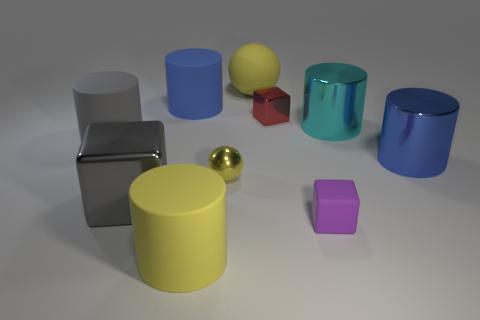How many other things are there of the same color as the rubber ball?
Offer a terse response. 2. What is the shape of the thing that is both behind the gray metallic thing and in front of the big blue metallic cylinder?
Make the answer very short. Sphere. Are there any red metal blocks that are on the left side of the big yellow rubber object in front of the cyan metallic cylinder to the right of the gray rubber cylinder?
Your answer should be compact. No. What number of other things are made of the same material as the red thing?
Ensure brevity in your answer.  4. How many yellow cylinders are there?
Your answer should be very brief. 1. How many things are either cylinders or big rubber cylinders behind the small purple matte cube?
Your answer should be compact. 5. Are there any other things that have the same shape as the big blue matte object?
Ensure brevity in your answer.  Yes. Is the size of the blue cylinder that is right of the yellow rubber cylinder the same as the big cyan cylinder?
Keep it short and to the point. Yes. What number of rubber objects are tiny yellow balls or big gray things?
Offer a very short reply. 1. What is the size of the shiny block behind the gray matte cylinder?
Make the answer very short. Small. 